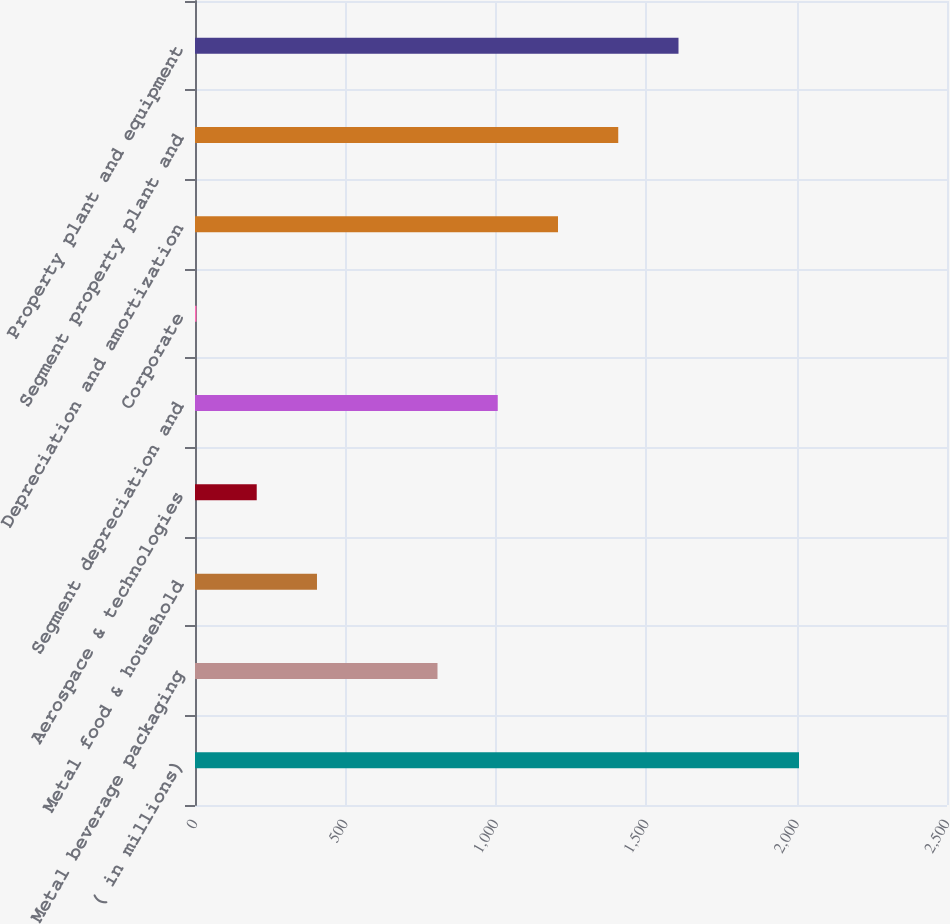Convert chart. <chart><loc_0><loc_0><loc_500><loc_500><bar_chart><fcel>( in millions)<fcel>Metal beverage packaging<fcel>Metal food & household<fcel>Aerospace & technologies<fcel>Segment depreciation and<fcel>Corporate<fcel>Depreciation and amortization<fcel>Segment property plant and<fcel>Property plant and equipment<nl><fcel>2008<fcel>806.14<fcel>405.52<fcel>205.21<fcel>1006.45<fcel>4.9<fcel>1206.76<fcel>1407.07<fcel>1607.38<nl></chart> 